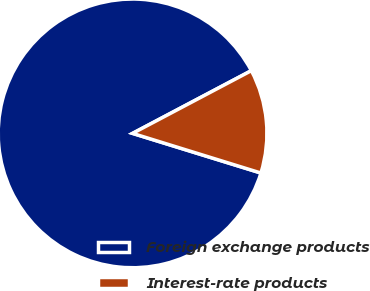Convert chart. <chart><loc_0><loc_0><loc_500><loc_500><pie_chart><fcel>Foreign exchange products<fcel>Interest-rate products<nl><fcel>87.5%<fcel>12.5%<nl></chart> 